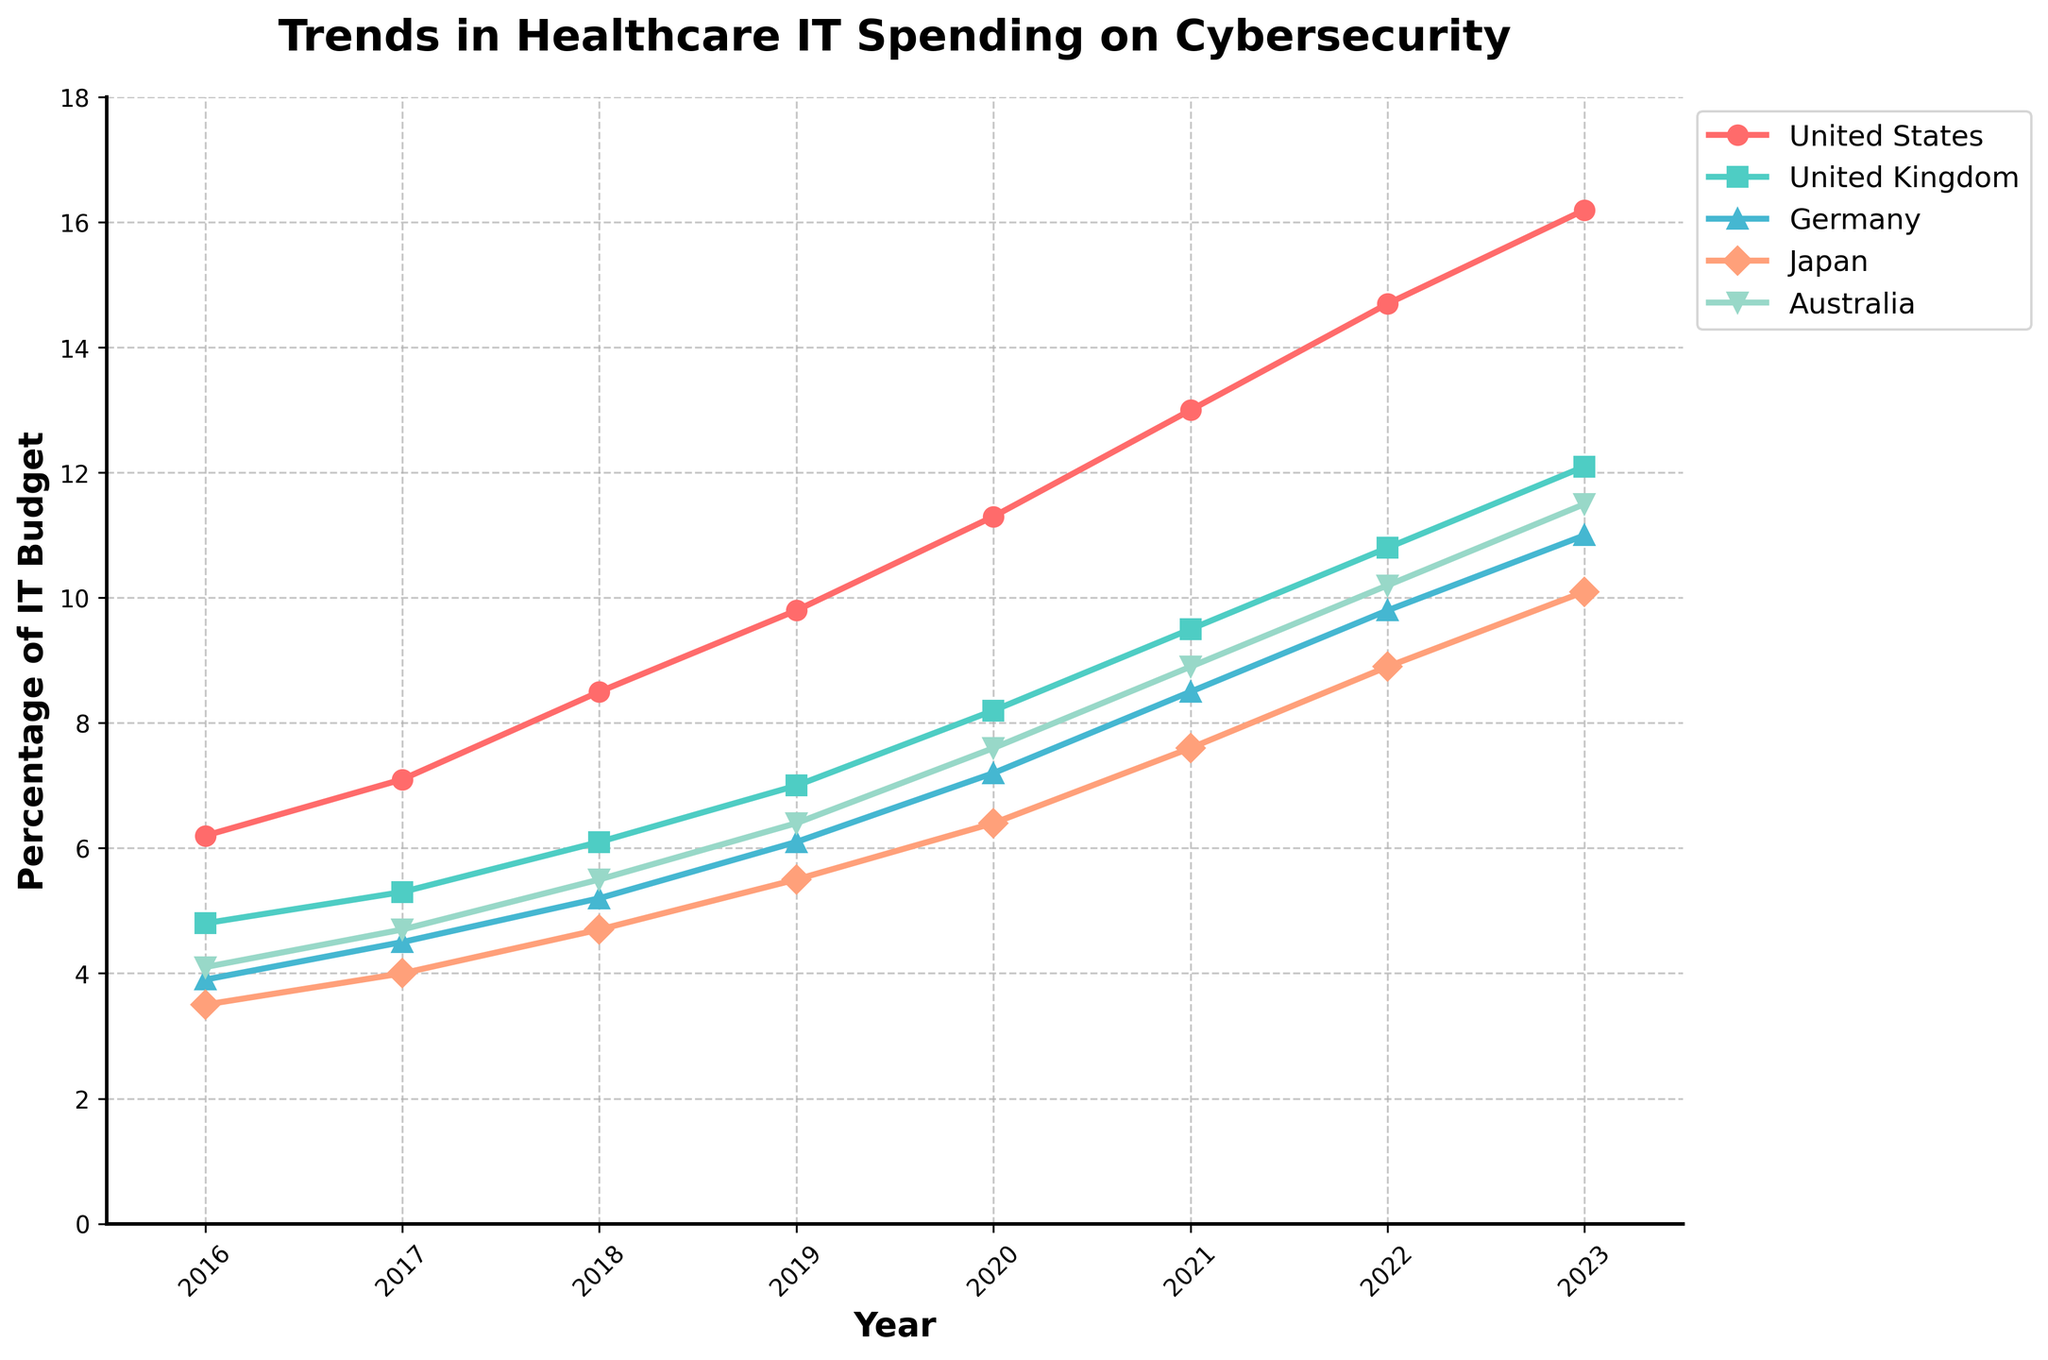What's the trend of United States' healthcare IT spending on cybersecurity from 2016 to 2023? The line for the United States trends upwards starting from 6.2% in 2016 to 16.2% in 2023.
Answer: Upward trend Which country had the highest increase in cybersecurity spending as a percentage of IT budget between 2016 and 2023? To determine this, calculate the difference for each country between 2023 and 2016. USA: 16.2 - 6.2 = 10. UK: 12.1 - 4.8 = 7.3. Germany: 11 - 3.9 = 7.1. Japan: 10.1 - 3.5 = 6.6. Australia: 11.5 - 4.1 = 7.4. USA had the highest increase.
Answer: USA What was the percentage of the IT budget allocated to cybersecurity in Germany in 2020? Refer to the figure and locate the point for Germany in 2020, which is at 7.2%.
Answer: 7.2% Which country had the smallest percentage of IT budget allocated to cybersecurity in 2016? Compare the percentages in 2016 across all countries in the figure. Japan had the smallest percentage at 3.5%.
Answer: Japan How does the trend in cybersecurity spending in Japan compare to Australia from 2016 to 2023? Compare the visual trends. Both Japan and Australia show an increasing trend, but Japan starts at a lower percentage (3.5%) and ends at 10.1%, while Australia starts at 4.1% and ends at 11.5%. Australia's line is slightly steeper.
Answer: Both increase, Australia has a steeper increase Which year did the United Kingdom exceed 10% in healthcare IT spending on cybersecurity? Locate the point on the UK line where it first goes above 10%, which is in 2022.
Answer: 2022 Between 2018 and 2019, which country had the largest increase in cybersecurity spending as a percentage of the IT budget? Calculate the difference for each country between 2019 and 2018. USA: 9.8 - 8.5 = 1.3. UK: 7.0 - 6.1 = 0.9. Germany: 6.1 - 5.2 = 0.9. Japan: 5.5 - 4.7 = 0.8. Australia: 6.4 - 5.5 = 0.9. The USA had the largest increase.
Answer: USA Which year did Germany's cybersecurity spending as a percentage of the IT budget first exceed 5%? Locate the point on Germany's line where it first goes above 5%, which is in 2018.
Answer: 2018 What is the average percentage of IT budget spent on cybersecurity in Australia from 2016 to 2023? Calculate the average of the percentages for Australia: (4.1 + 4.7 + 5.5 + 6.4 + 7.6 + 8.9 + 10.2 + 11.5) / 8 ≈ 7.36%.
Answer: 7.36% Which country shows the most consistent yearly increase in cybersecurity spending as a percentage of the IT budget? Visually, the USA shows an even and consistent upward trend without any dips.
Answer: USA 